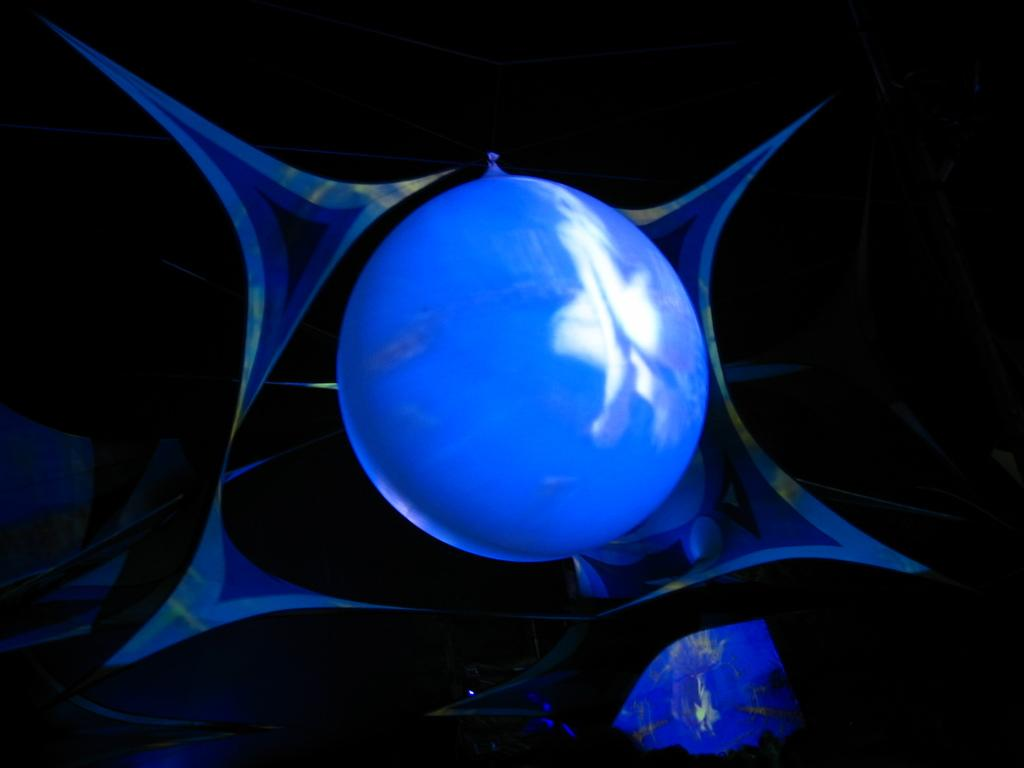What color is the balloon in the image? The balloon in the image is blue. Where is the balloon located in the image? The balloon is in the middle of the image. What type of horn does your aunt play in the image? There is no mention of an aunt or a horn in the image; it only features a blue balloon. 